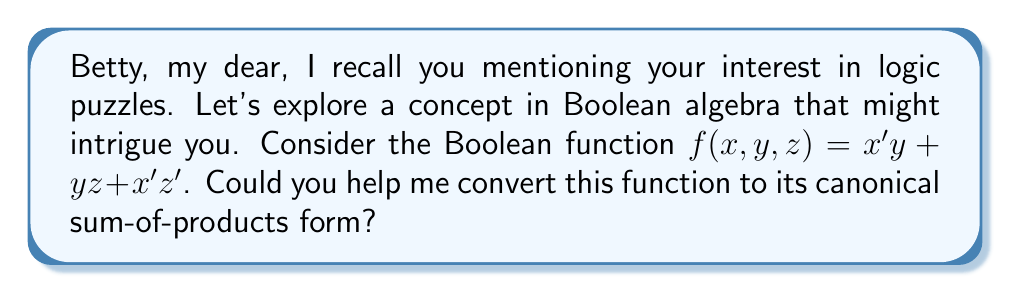Teach me how to tackle this problem. Certainly, Betty. Let's approach this step-by-step:

1) First, we need to understand what a canonical sum-of-products (SOP) form is. It's a sum of minterms, where each minterm is a product term in which each variable appears exactly once, either complemented or uncomplemented.

2) Our function $f(x,y,z) = x'y + yz + x'z'$ is not in canonical SOP form because not all variables appear in each term.

3) Let's expand each term to include all variables:

   $x'y = x'y(z + z') = x'yz + x'yz'$
   $yz = yz(x + x') = xyz + x'yz$
   $x'z' = x'z'(y + y') = x'yz' + x'y'z'$

4) Now our function becomes:
   $f(x,y,z) = x'yz + x'yz' + xyz + x'yz + x'yz' + x'y'z'$

5) Simplify by combining like terms:
   $f(x,y,z) = x'yz + x'yz' + xyz + x'y'z'$

6) Each term now includes all variables and is a minterm. This is the canonical SOP form.

7) We can also represent this using sigma notation:
   $f(x,y,z) = \sum m(2,3,6,7)$

   Where 2, 3, 6, and 7 are the decimal equivalents of the binary representations of the minterms.
Answer: $f(x,y,z) = x'yz + x'yz' + xyz + x'y'z'$ or $\sum m(2,3,6,7)$ 